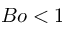<formula> <loc_0><loc_0><loc_500><loc_500>B o < 1</formula> 